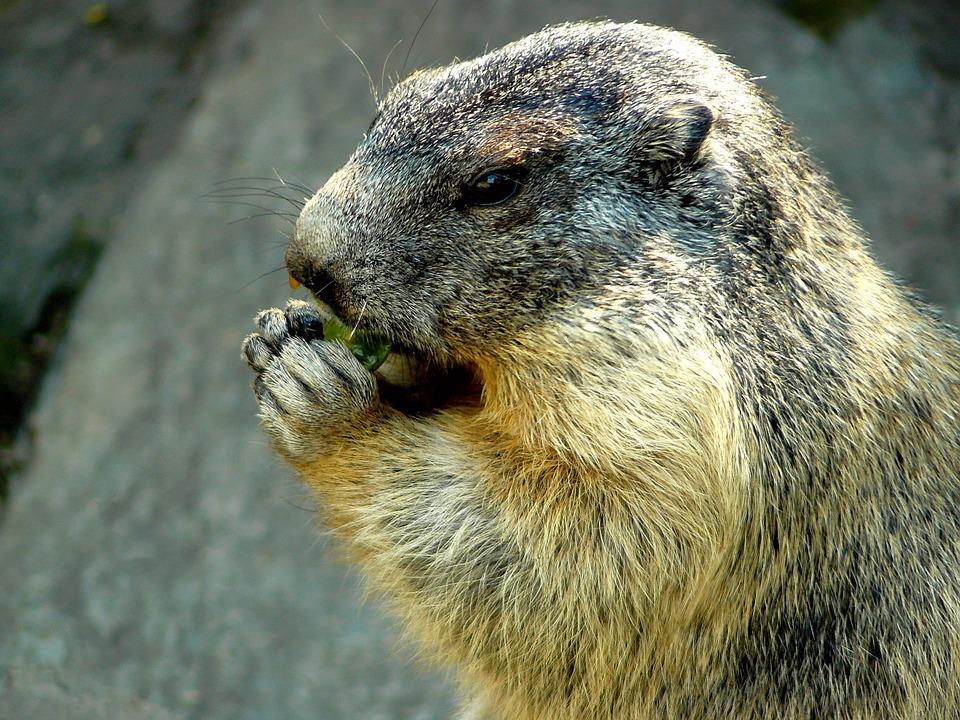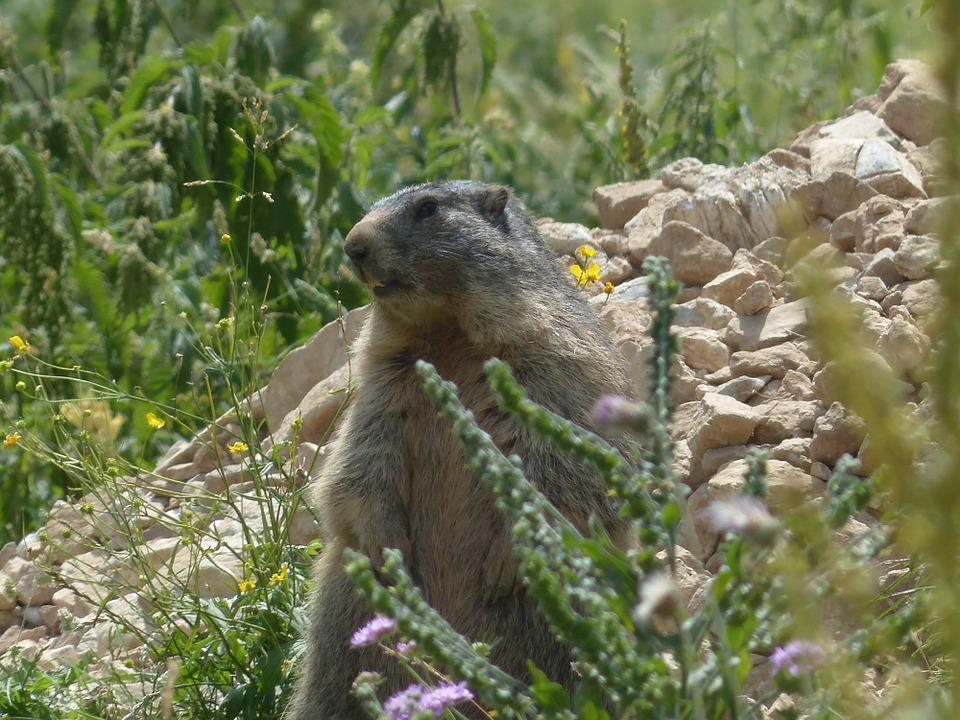The first image is the image on the left, the second image is the image on the right. Assess this claim about the two images: "An image shows marmot with hands raised and close to each other.". Correct or not? Answer yes or no. Yes. The first image is the image on the left, the second image is the image on the right. Examine the images to the left and right. Is the description "In 1 of the images, 1 groundhog is holding an object with its forelimbs." accurate? Answer yes or no. Yes. 